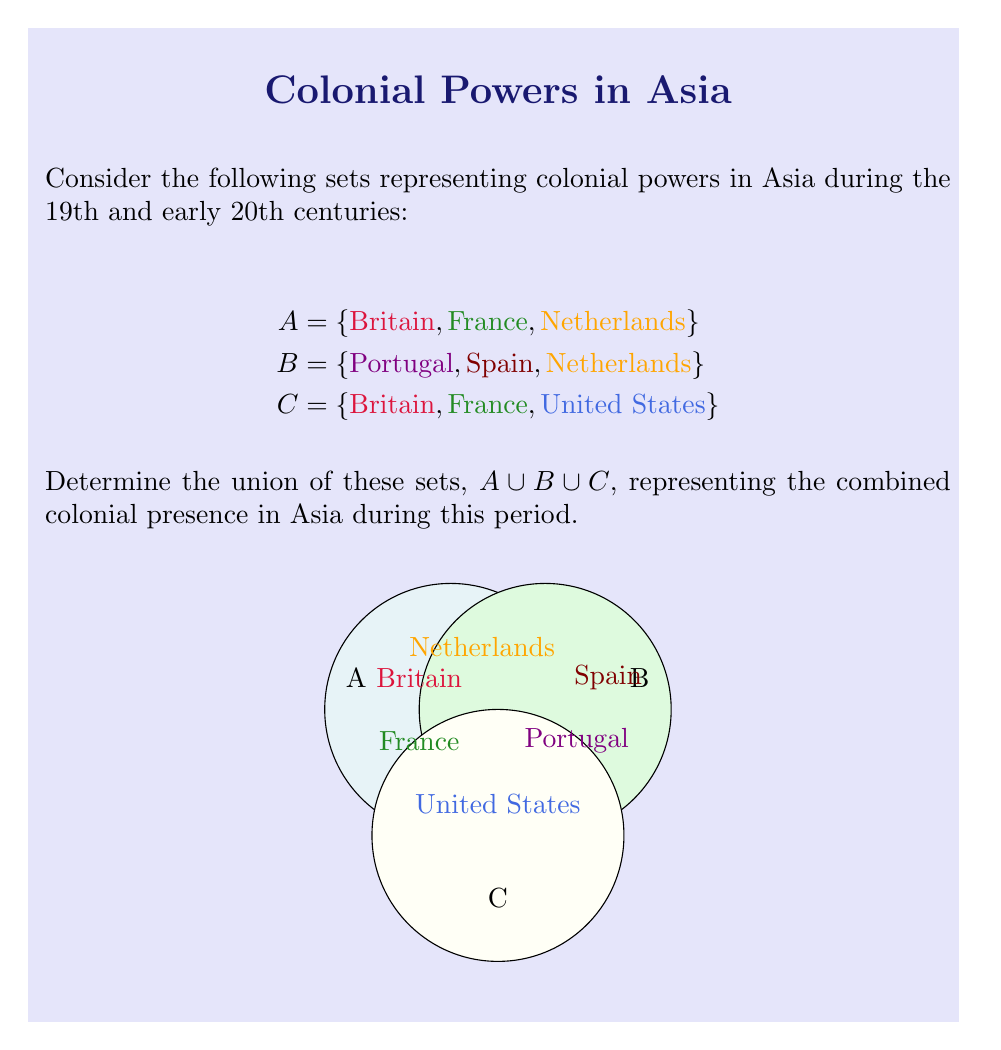What is the answer to this math problem? To find the union of sets A, B, and C, we need to combine all unique elements from these sets. Let's approach this step-by-step:

1) First, let's list out all elements in each set:
   $A = \{Britain, France, Netherlands\}$
   $B = \{Portugal, Spain, Netherlands\}$
   $C = \{Britain, France, United States\}$

2) Now, we'll start building our union set by including all elements from set A:
   $A \cup B \cup C = \{Britain, France, Netherlands\}$

3) Next, we'll add any elements from set B that are not already in our union set:
   - Portugal and Spain are not in our set yet, so we add them.
   - Netherlands is already included, so we don't need to add it again.
   $A \cup B \cup C = \{Britain, France, Netherlands, Portugal, Spain\}$

4) Finally, we'll add any elements from set C that are not already in our union set:
   - Britain and France are already included.
   - United States is not in our set yet, so we add it.
   $A \cup B \cup C = \{Britain, France, Netherlands, Portugal, Spain, United States\}$

5) We have now included all unique elements from sets A, B, and C in our union set.

In set theory notation, we can write this as:
$$A \cup B \cup C = \{x | x \in A \lor x \in B \lor x \in C\}$$

Where $\lor$ represents the logical OR operation.
Answer: $\{Britain, France, Netherlands, Portugal, Spain, United States\}$ 